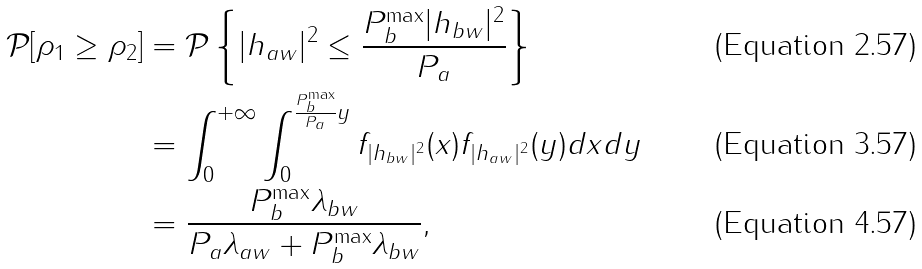Convert formula to latex. <formula><loc_0><loc_0><loc_500><loc_500>\mathcal { P } [ \rho _ { 1 } \geq \rho _ { 2 } ] & = \mathcal { P } \left \{ | h _ { a w } | ^ { 2 } \leq \frac { P _ { b } ^ { \max } | h _ { b w } | ^ { 2 } } { P _ { a } } \right \} \\ & = \int _ { 0 } ^ { + \infty } \int _ { 0 } ^ { \frac { P _ { b } ^ { \max } } { P _ { a } } y } f _ { | h _ { b w } | ^ { 2 } } ( x ) f _ { | h _ { a w } | ^ { 2 } } ( y ) d x d y \\ & = \frac { P _ { b } ^ { \max } \lambda _ { b w } } { P _ { a } \lambda _ { a w } + P _ { b } ^ { \max } \lambda _ { b w } } ,</formula> 